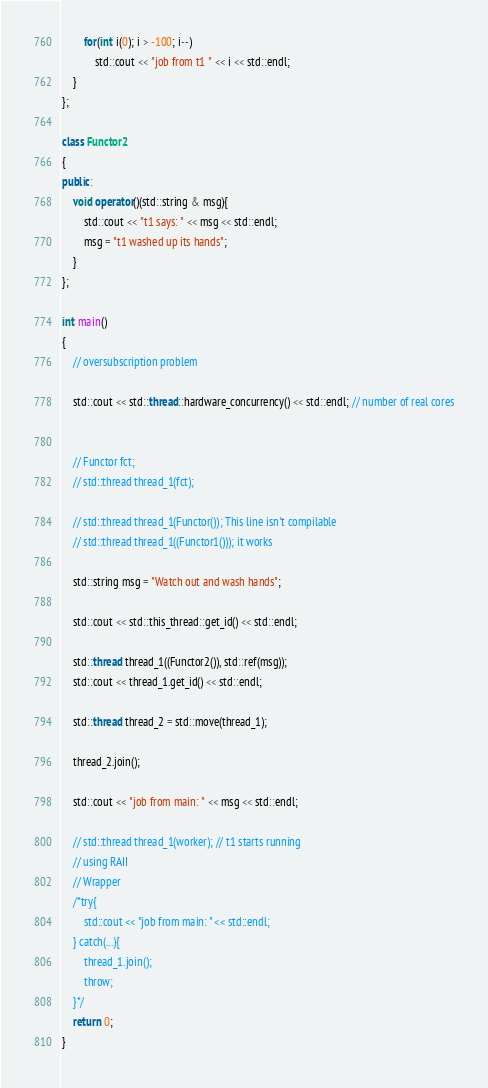<code> <loc_0><loc_0><loc_500><loc_500><_C++_>		for(int i(0); i > -100; i--)
			std::cout << "job from t1 " << i << std::endl;
	}
};

class Functor2
{
public:
	void operator()(std::string & msg){
		std::cout << "t1 says: " << msg << std::endl;
		msg = "t1 washed up its hands";
	}
};

int main()
{
	// oversubscription problem

	std::cout << std::thread::hardware_concurrency() << std::endl; // number of real cores


	// Functor fct;
	// std::thread thread_1(fct);
	
	// std::thread thread_1(Functor()); This line isn't compilable
	// std::thread thread_1((Functor1())); it works

	std::string msg = "Watch out and wash hands";

	std::cout << std::this_thread::get_id() << std::endl;

	std::thread thread_1((Functor2()), std::ref(msg));
	std::cout << thread_1.get_id() << std::endl;

	std::thread thread_2 = std::move(thread_1);

	thread_2.join();

	std::cout << "job from main: " << msg << std::endl;

	// std::thread thread_1(worker); // t1 starts running
	// using RAII
	// Wrapper
	/*try{
		std::cout << "job from main: " << std::endl;
	} catch(...){
		thread_1.join();
		throw;
	}*/
	return 0;
}
</code> 